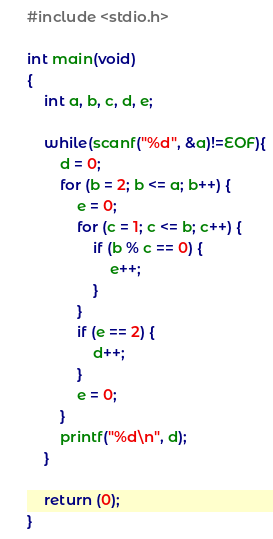Convert code to text. <code><loc_0><loc_0><loc_500><loc_500><_C_>#include <stdio.h>

int main(void)
{
	int a, b, c, d, e;
	
	while(scanf("%d", &a)!=EOF){
		d = 0;
		for (b = 2; b <= a; b++) {
			e = 0;
			for (c = 1; c <= b; c++) {
				if (b % c == 0) {
					e++;
				}
			}
			if (e == 2) {
				d++;
			}
			e = 0;
		}
		printf("%d\n", d);
	}
	
	return (0);
}	</code> 